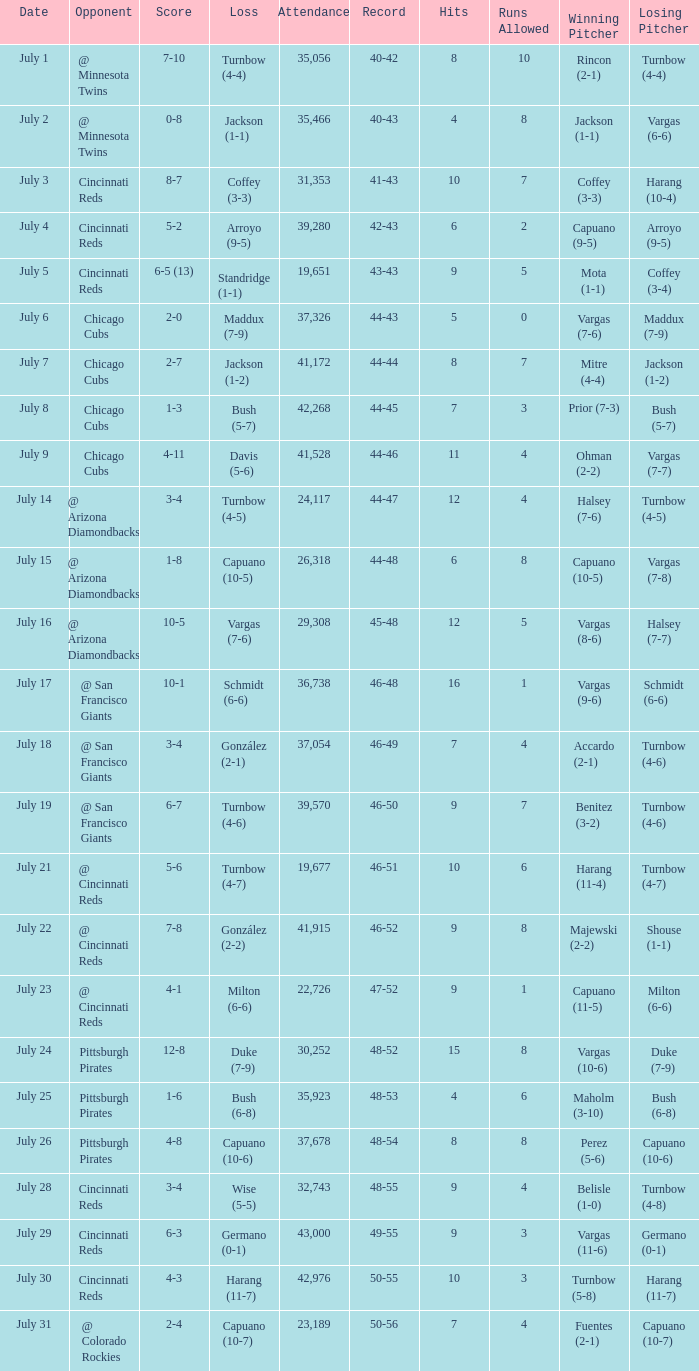What was the record at the game that had a score of 7-10? 40-42. 